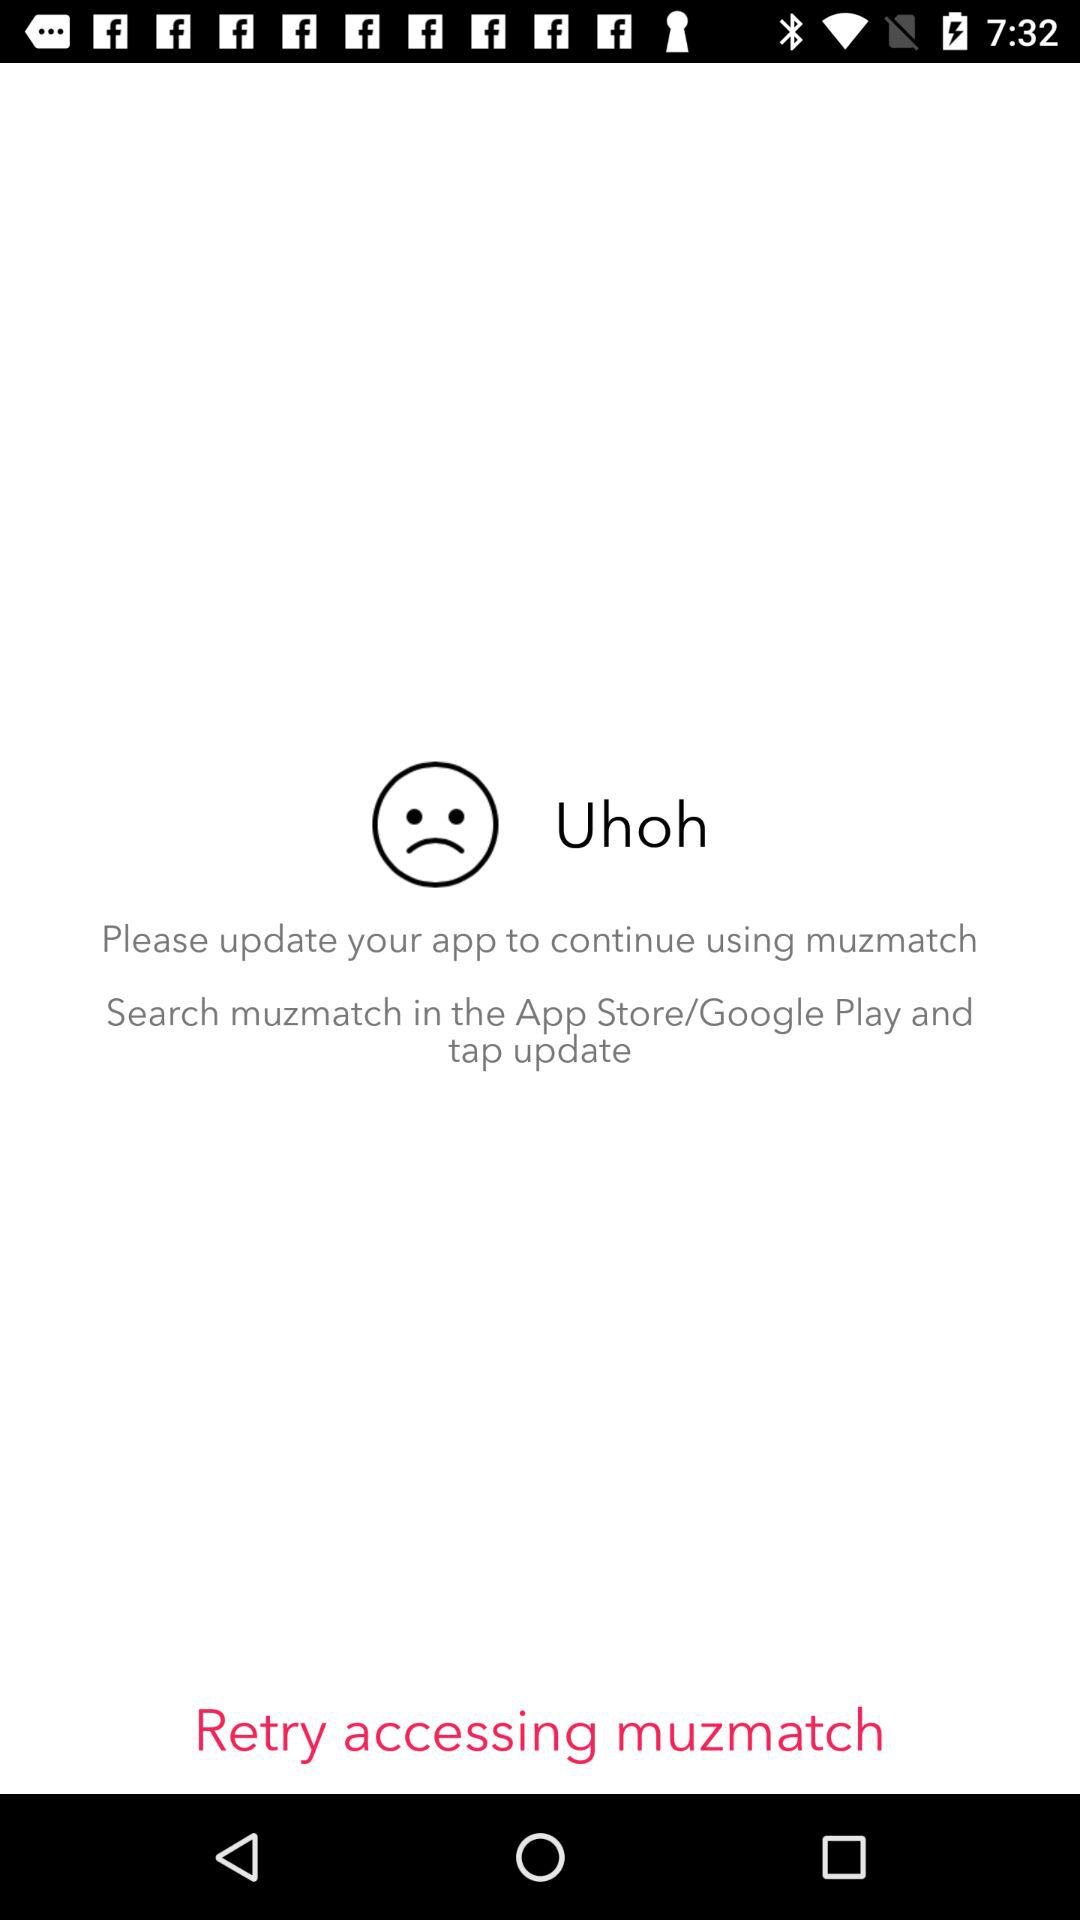What is the application name? The application name is "muzmatch". 